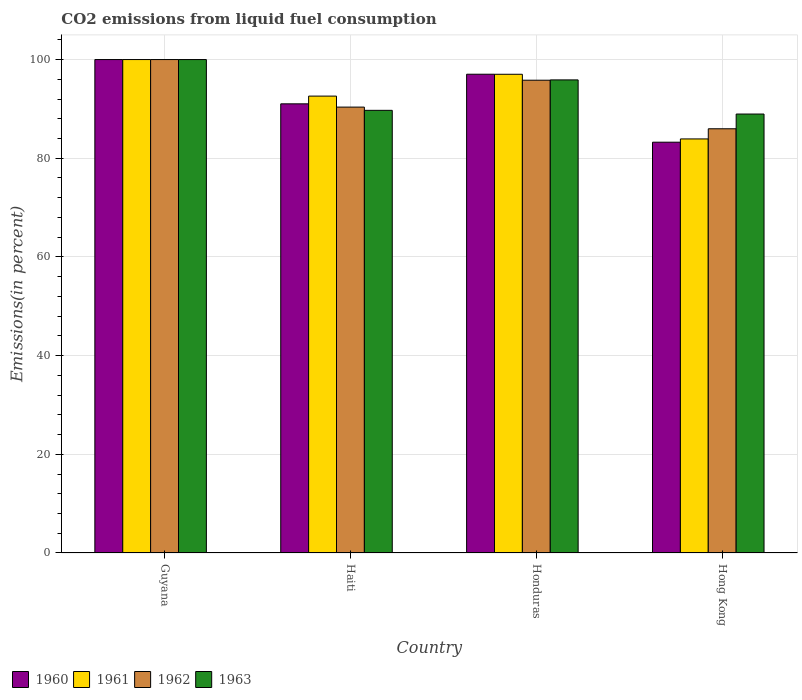How many groups of bars are there?
Your answer should be compact. 4. Are the number of bars per tick equal to the number of legend labels?
Provide a succinct answer. Yes. Are the number of bars on each tick of the X-axis equal?
Your response must be concise. Yes. What is the label of the 1st group of bars from the left?
Your response must be concise. Guyana. What is the total CO2 emitted in 1960 in Honduras?
Offer a very short reply. 97.02. Across all countries, what is the minimum total CO2 emitted in 1961?
Give a very brief answer. 83.91. In which country was the total CO2 emitted in 1961 maximum?
Offer a terse response. Guyana. In which country was the total CO2 emitted in 1960 minimum?
Give a very brief answer. Hong Kong. What is the total total CO2 emitted in 1960 in the graph?
Your response must be concise. 371.3. What is the difference between the total CO2 emitted in 1962 in Guyana and that in Hong Kong?
Give a very brief answer. 14.03. What is the difference between the total CO2 emitted in 1960 in Haiti and the total CO2 emitted in 1962 in Guyana?
Make the answer very short. -8.97. What is the average total CO2 emitted in 1963 per country?
Give a very brief answer. 93.63. What is the difference between the total CO2 emitted of/in 1962 and total CO2 emitted of/in 1961 in Haiti?
Make the answer very short. -2.23. What is the ratio of the total CO2 emitted in 1963 in Honduras to that in Hong Kong?
Provide a succinct answer. 1.08. What is the difference between the highest and the second highest total CO2 emitted in 1963?
Make the answer very short. -10.29. What is the difference between the highest and the lowest total CO2 emitted in 1961?
Ensure brevity in your answer.  16.09. In how many countries, is the total CO2 emitted in 1961 greater than the average total CO2 emitted in 1961 taken over all countries?
Provide a short and direct response. 2. Is the sum of the total CO2 emitted in 1961 in Guyana and Honduras greater than the maximum total CO2 emitted in 1963 across all countries?
Provide a short and direct response. Yes. What does the 1st bar from the left in Guyana represents?
Keep it short and to the point. 1960. What does the 2nd bar from the right in Haiti represents?
Your answer should be very brief. 1962. How many bars are there?
Keep it short and to the point. 16. How many countries are there in the graph?
Your response must be concise. 4. What is the difference between two consecutive major ticks on the Y-axis?
Provide a succinct answer. 20. How are the legend labels stacked?
Give a very brief answer. Horizontal. What is the title of the graph?
Offer a very short reply. CO2 emissions from liquid fuel consumption. Does "2004" appear as one of the legend labels in the graph?
Provide a short and direct response. No. What is the label or title of the Y-axis?
Provide a succinct answer. Emissions(in percent). What is the Emissions(in percent) of 1961 in Guyana?
Your response must be concise. 100. What is the Emissions(in percent) in 1960 in Haiti?
Provide a short and direct response. 91.03. What is the Emissions(in percent) in 1961 in Haiti?
Your answer should be very brief. 92.59. What is the Emissions(in percent) of 1962 in Haiti?
Provide a succinct answer. 90.36. What is the Emissions(in percent) in 1963 in Haiti?
Offer a very short reply. 89.71. What is the Emissions(in percent) of 1960 in Honduras?
Make the answer very short. 97.02. What is the Emissions(in percent) in 1961 in Honduras?
Your answer should be very brief. 97.01. What is the Emissions(in percent) in 1962 in Honduras?
Provide a short and direct response. 95.81. What is the Emissions(in percent) in 1963 in Honduras?
Offer a terse response. 95.88. What is the Emissions(in percent) in 1960 in Hong Kong?
Give a very brief answer. 83.25. What is the Emissions(in percent) of 1961 in Hong Kong?
Your answer should be very brief. 83.91. What is the Emissions(in percent) in 1962 in Hong Kong?
Provide a short and direct response. 85.97. What is the Emissions(in percent) of 1963 in Hong Kong?
Offer a terse response. 88.96. Across all countries, what is the maximum Emissions(in percent) in 1962?
Ensure brevity in your answer.  100. Across all countries, what is the maximum Emissions(in percent) of 1963?
Provide a short and direct response. 100. Across all countries, what is the minimum Emissions(in percent) of 1960?
Ensure brevity in your answer.  83.25. Across all countries, what is the minimum Emissions(in percent) in 1961?
Make the answer very short. 83.91. Across all countries, what is the minimum Emissions(in percent) of 1962?
Make the answer very short. 85.97. Across all countries, what is the minimum Emissions(in percent) of 1963?
Your answer should be very brief. 88.96. What is the total Emissions(in percent) in 1960 in the graph?
Make the answer very short. 371.3. What is the total Emissions(in percent) in 1961 in the graph?
Keep it short and to the point. 373.52. What is the total Emissions(in percent) in 1962 in the graph?
Provide a short and direct response. 372.14. What is the total Emissions(in percent) in 1963 in the graph?
Your response must be concise. 374.54. What is the difference between the Emissions(in percent) in 1960 in Guyana and that in Haiti?
Your answer should be very brief. 8.97. What is the difference between the Emissions(in percent) in 1961 in Guyana and that in Haiti?
Your answer should be very brief. 7.41. What is the difference between the Emissions(in percent) in 1962 in Guyana and that in Haiti?
Your response must be concise. 9.64. What is the difference between the Emissions(in percent) in 1963 in Guyana and that in Haiti?
Provide a short and direct response. 10.29. What is the difference between the Emissions(in percent) in 1960 in Guyana and that in Honduras?
Give a very brief answer. 2.98. What is the difference between the Emissions(in percent) in 1961 in Guyana and that in Honduras?
Give a very brief answer. 2.99. What is the difference between the Emissions(in percent) of 1962 in Guyana and that in Honduras?
Your response must be concise. 4.19. What is the difference between the Emissions(in percent) in 1963 in Guyana and that in Honduras?
Provide a short and direct response. 4.12. What is the difference between the Emissions(in percent) in 1960 in Guyana and that in Hong Kong?
Provide a short and direct response. 16.75. What is the difference between the Emissions(in percent) in 1961 in Guyana and that in Hong Kong?
Give a very brief answer. 16.09. What is the difference between the Emissions(in percent) in 1962 in Guyana and that in Hong Kong?
Your answer should be very brief. 14.03. What is the difference between the Emissions(in percent) of 1963 in Guyana and that in Hong Kong?
Your answer should be very brief. 11.04. What is the difference between the Emissions(in percent) of 1960 in Haiti and that in Honduras?
Provide a short and direct response. -6. What is the difference between the Emissions(in percent) of 1961 in Haiti and that in Honduras?
Your answer should be compact. -4.42. What is the difference between the Emissions(in percent) in 1962 in Haiti and that in Honduras?
Give a very brief answer. -5.45. What is the difference between the Emissions(in percent) in 1963 in Haiti and that in Honduras?
Keep it short and to the point. -6.17. What is the difference between the Emissions(in percent) in 1960 in Haiti and that in Hong Kong?
Your answer should be compact. 7.78. What is the difference between the Emissions(in percent) in 1961 in Haiti and that in Hong Kong?
Offer a terse response. 8.68. What is the difference between the Emissions(in percent) in 1962 in Haiti and that in Hong Kong?
Offer a very short reply. 4.39. What is the difference between the Emissions(in percent) in 1963 in Haiti and that in Hong Kong?
Your answer should be compact. 0.75. What is the difference between the Emissions(in percent) of 1960 in Honduras and that in Hong Kong?
Provide a succinct answer. 13.77. What is the difference between the Emissions(in percent) of 1961 in Honduras and that in Hong Kong?
Give a very brief answer. 13.1. What is the difference between the Emissions(in percent) in 1962 in Honduras and that in Hong Kong?
Your answer should be very brief. 9.84. What is the difference between the Emissions(in percent) in 1963 in Honduras and that in Hong Kong?
Provide a short and direct response. 6.92. What is the difference between the Emissions(in percent) of 1960 in Guyana and the Emissions(in percent) of 1961 in Haiti?
Provide a short and direct response. 7.41. What is the difference between the Emissions(in percent) in 1960 in Guyana and the Emissions(in percent) in 1962 in Haiti?
Offer a very short reply. 9.64. What is the difference between the Emissions(in percent) of 1960 in Guyana and the Emissions(in percent) of 1963 in Haiti?
Your response must be concise. 10.29. What is the difference between the Emissions(in percent) of 1961 in Guyana and the Emissions(in percent) of 1962 in Haiti?
Your response must be concise. 9.64. What is the difference between the Emissions(in percent) of 1961 in Guyana and the Emissions(in percent) of 1963 in Haiti?
Offer a terse response. 10.29. What is the difference between the Emissions(in percent) of 1962 in Guyana and the Emissions(in percent) of 1963 in Haiti?
Provide a succinct answer. 10.29. What is the difference between the Emissions(in percent) in 1960 in Guyana and the Emissions(in percent) in 1961 in Honduras?
Your answer should be very brief. 2.99. What is the difference between the Emissions(in percent) in 1960 in Guyana and the Emissions(in percent) in 1962 in Honduras?
Keep it short and to the point. 4.19. What is the difference between the Emissions(in percent) in 1960 in Guyana and the Emissions(in percent) in 1963 in Honduras?
Your answer should be very brief. 4.12. What is the difference between the Emissions(in percent) of 1961 in Guyana and the Emissions(in percent) of 1962 in Honduras?
Your answer should be very brief. 4.19. What is the difference between the Emissions(in percent) in 1961 in Guyana and the Emissions(in percent) in 1963 in Honduras?
Ensure brevity in your answer.  4.12. What is the difference between the Emissions(in percent) in 1962 in Guyana and the Emissions(in percent) in 1963 in Honduras?
Your answer should be very brief. 4.12. What is the difference between the Emissions(in percent) in 1960 in Guyana and the Emissions(in percent) in 1961 in Hong Kong?
Make the answer very short. 16.09. What is the difference between the Emissions(in percent) in 1960 in Guyana and the Emissions(in percent) in 1962 in Hong Kong?
Your answer should be compact. 14.03. What is the difference between the Emissions(in percent) in 1960 in Guyana and the Emissions(in percent) in 1963 in Hong Kong?
Make the answer very short. 11.04. What is the difference between the Emissions(in percent) in 1961 in Guyana and the Emissions(in percent) in 1962 in Hong Kong?
Provide a succinct answer. 14.03. What is the difference between the Emissions(in percent) of 1961 in Guyana and the Emissions(in percent) of 1963 in Hong Kong?
Your answer should be compact. 11.04. What is the difference between the Emissions(in percent) of 1962 in Guyana and the Emissions(in percent) of 1963 in Hong Kong?
Ensure brevity in your answer.  11.04. What is the difference between the Emissions(in percent) in 1960 in Haiti and the Emissions(in percent) in 1961 in Honduras?
Make the answer very short. -5.99. What is the difference between the Emissions(in percent) in 1960 in Haiti and the Emissions(in percent) in 1962 in Honduras?
Ensure brevity in your answer.  -4.79. What is the difference between the Emissions(in percent) of 1960 in Haiti and the Emissions(in percent) of 1963 in Honduras?
Offer a terse response. -4.85. What is the difference between the Emissions(in percent) of 1961 in Haiti and the Emissions(in percent) of 1962 in Honduras?
Offer a very short reply. -3.22. What is the difference between the Emissions(in percent) of 1961 in Haiti and the Emissions(in percent) of 1963 in Honduras?
Provide a succinct answer. -3.28. What is the difference between the Emissions(in percent) in 1962 in Haiti and the Emissions(in percent) in 1963 in Honduras?
Your answer should be compact. -5.51. What is the difference between the Emissions(in percent) of 1960 in Haiti and the Emissions(in percent) of 1961 in Hong Kong?
Keep it short and to the point. 7.11. What is the difference between the Emissions(in percent) in 1960 in Haiti and the Emissions(in percent) in 1962 in Hong Kong?
Your answer should be very brief. 5.06. What is the difference between the Emissions(in percent) of 1960 in Haiti and the Emissions(in percent) of 1963 in Hong Kong?
Give a very brief answer. 2.07. What is the difference between the Emissions(in percent) of 1961 in Haiti and the Emissions(in percent) of 1962 in Hong Kong?
Offer a terse response. 6.62. What is the difference between the Emissions(in percent) of 1961 in Haiti and the Emissions(in percent) of 1963 in Hong Kong?
Provide a short and direct response. 3.64. What is the difference between the Emissions(in percent) in 1962 in Haiti and the Emissions(in percent) in 1963 in Hong Kong?
Provide a short and direct response. 1.41. What is the difference between the Emissions(in percent) in 1960 in Honduras and the Emissions(in percent) in 1961 in Hong Kong?
Keep it short and to the point. 13.11. What is the difference between the Emissions(in percent) of 1960 in Honduras and the Emissions(in percent) of 1962 in Hong Kong?
Provide a succinct answer. 11.05. What is the difference between the Emissions(in percent) in 1960 in Honduras and the Emissions(in percent) in 1963 in Hong Kong?
Your answer should be compact. 8.07. What is the difference between the Emissions(in percent) of 1961 in Honduras and the Emissions(in percent) of 1962 in Hong Kong?
Offer a very short reply. 11.04. What is the difference between the Emissions(in percent) of 1961 in Honduras and the Emissions(in percent) of 1963 in Hong Kong?
Your answer should be compact. 8.06. What is the difference between the Emissions(in percent) in 1962 in Honduras and the Emissions(in percent) in 1963 in Hong Kong?
Your response must be concise. 6.86. What is the average Emissions(in percent) of 1960 per country?
Give a very brief answer. 92.83. What is the average Emissions(in percent) in 1961 per country?
Make the answer very short. 93.38. What is the average Emissions(in percent) of 1962 per country?
Make the answer very short. 93.04. What is the average Emissions(in percent) in 1963 per country?
Provide a succinct answer. 93.63. What is the difference between the Emissions(in percent) in 1960 and Emissions(in percent) in 1963 in Guyana?
Ensure brevity in your answer.  0. What is the difference between the Emissions(in percent) in 1961 and Emissions(in percent) in 1962 in Guyana?
Provide a succinct answer. 0. What is the difference between the Emissions(in percent) in 1961 and Emissions(in percent) in 1963 in Guyana?
Make the answer very short. 0. What is the difference between the Emissions(in percent) in 1960 and Emissions(in percent) in 1961 in Haiti?
Your answer should be very brief. -1.57. What is the difference between the Emissions(in percent) in 1960 and Emissions(in percent) in 1962 in Haiti?
Your answer should be compact. 0.66. What is the difference between the Emissions(in percent) in 1960 and Emissions(in percent) in 1963 in Haiti?
Provide a succinct answer. 1.32. What is the difference between the Emissions(in percent) in 1961 and Emissions(in percent) in 1962 in Haiti?
Provide a succinct answer. 2.23. What is the difference between the Emissions(in percent) in 1961 and Emissions(in percent) in 1963 in Haiti?
Offer a very short reply. 2.89. What is the difference between the Emissions(in percent) of 1962 and Emissions(in percent) of 1963 in Haiti?
Give a very brief answer. 0.66. What is the difference between the Emissions(in percent) of 1960 and Emissions(in percent) of 1961 in Honduras?
Keep it short and to the point. 0.01. What is the difference between the Emissions(in percent) of 1960 and Emissions(in percent) of 1962 in Honduras?
Your answer should be compact. 1.21. What is the difference between the Emissions(in percent) in 1960 and Emissions(in percent) in 1963 in Honduras?
Your answer should be compact. 1.15. What is the difference between the Emissions(in percent) in 1961 and Emissions(in percent) in 1962 in Honduras?
Your response must be concise. 1.2. What is the difference between the Emissions(in percent) in 1961 and Emissions(in percent) in 1963 in Honduras?
Provide a succinct answer. 1.14. What is the difference between the Emissions(in percent) of 1962 and Emissions(in percent) of 1963 in Honduras?
Offer a terse response. -0.06. What is the difference between the Emissions(in percent) in 1960 and Emissions(in percent) in 1961 in Hong Kong?
Keep it short and to the point. -0.66. What is the difference between the Emissions(in percent) of 1960 and Emissions(in percent) of 1962 in Hong Kong?
Give a very brief answer. -2.72. What is the difference between the Emissions(in percent) in 1960 and Emissions(in percent) in 1963 in Hong Kong?
Provide a succinct answer. -5.71. What is the difference between the Emissions(in percent) of 1961 and Emissions(in percent) of 1962 in Hong Kong?
Keep it short and to the point. -2.06. What is the difference between the Emissions(in percent) in 1961 and Emissions(in percent) in 1963 in Hong Kong?
Your answer should be very brief. -5.04. What is the difference between the Emissions(in percent) in 1962 and Emissions(in percent) in 1963 in Hong Kong?
Give a very brief answer. -2.99. What is the ratio of the Emissions(in percent) of 1960 in Guyana to that in Haiti?
Provide a short and direct response. 1.1. What is the ratio of the Emissions(in percent) in 1961 in Guyana to that in Haiti?
Ensure brevity in your answer.  1.08. What is the ratio of the Emissions(in percent) in 1962 in Guyana to that in Haiti?
Provide a short and direct response. 1.11. What is the ratio of the Emissions(in percent) in 1963 in Guyana to that in Haiti?
Your answer should be very brief. 1.11. What is the ratio of the Emissions(in percent) of 1960 in Guyana to that in Honduras?
Give a very brief answer. 1.03. What is the ratio of the Emissions(in percent) of 1961 in Guyana to that in Honduras?
Ensure brevity in your answer.  1.03. What is the ratio of the Emissions(in percent) of 1962 in Guyana to that in Honduras?
Keep it short and to the point. 1.04. What is the ratio of the Emissions(in percent) of 1963 in Guyana to that in Honduras?
Give a very brief answer. 1.04. What is the ratio of the Emissions(in percent) of 1960 in Guyana to that in Hong Kong?
Make the answer very short. 1.2. What is the ratio of the Emissions(in percent) of 1961 in Guyana to that in Hong Kong?
Your answer should be compact. 1.19. What is the ratio of the Emissions(in percent) in 1962 in Guyana to that in Hong Kong?
Offer a terse response. 1.16. What is the ratio of the Emissions(in percent) in 1963 in Guyana to that in Hong Kong?
Give a very brief answer. 1.12. What is the ratio of the Emissions(in percent) in 1960 in Haiti to that in Honduras?
Provide a short and direct response. 0.94. What is the ratio of the Emissions(in percent) of 1961 in Haiti to that in Honduras?
Your response must be concise. 0.95. What is the ratio of the Emissions(in percent) in 1962 in Haiti to that in Honduras?
Your answer should be very brief. 0.94. What is the ratio of the Emissions(in percent) in 1963 in Haiti to that in Honduras?
Your response must be concise. 0.94. What is the ratio of the Emissions(in percent) in 1960 in Haiti to that in Hong Kong?
Provide a short and direct response. 1.09. What is the ratio of the Emissions(in percent) of 1961 in Haiti to that in Hong Kong?
Your response must be concise. 1.1. What is the ratio of the Emissions(in percent) of 1962 in Haiti to that in Hong Kong?
Your answer should be compact. 1.05. What is the ratio of the Emissions(in percent) of 1963 in Haiti to that in Hong Kong?
Offer a very short reply. 1.01. What is the ratio of the Emissions(in percent) in 1960 in Honduras to that in Hong Kong?
Make the answer very short. 1.17. What is the ratio of the Emissions(in percent) of 1961 in Honduras to that in Hong Kong?
Your answer should be compact. 1.16. What is the ratio of the Emissions(in percent) of 1962 in Honduras to that in Hong Kong?
Provide a succinct answer. 1.11. What is the ratio of the Emissions(in percent) of 1963 in Honduras to that in Hong Kong?
Ensure brevity in your answer.  1.08. What is the difference between the highest and the second highest Emissions(in percent) of 1960?
Your answer should be very brief. 2.98. What is the difference between the highest and the second highest Emissions(in percent) in 1961?
Ensure brevity in your answer.  2.99. What is the difference between the highest and the second highest Emissions(in percent) in 1962?
Make the answer very short. 4.19. What is the difference between the highest and the second highest Emissions(in percent) in 1963?
Offer a very short reply. 4.12. What is the difference between the highest and the lowest Emissions(in percent) of 1960?
Ensure brevity in your answer.  16.75. What is the difference between the highest and the lowest Emissions(in percent) of 1961?
Provide a short and direct response. 16.09. What is the difference between the highest and the lowest Emissions(in percent) in 1962?
Your response must be concise. 14.03. What is the difference between the highest and the lowest Emissions(in percent) of 1963?
Offer a very short reply. 11.04. 